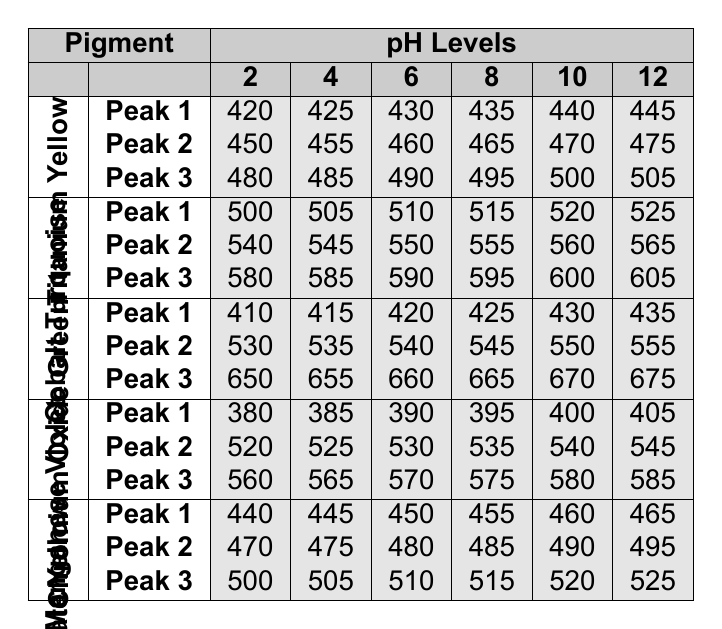What is the absorption peak of Titanium Yellow at pH level 6? By referring to the table, the absorption peak for Titanium Yellow at pH level 6 is specifically listed under Peak 1, Peak 2, and Peak 3. For Peak 1, the value is 430.
Answer: 430 What is the highest absorption value of Cobalt Turquoise at pH level 10? The table shows that for Cobalt Turquoise at pH level 10, the absorption peaks are 520, 560, and 600. Among these, 600 is the highest.
Answer: 600 Which pigment has the lowest absorption peak at pH level 2? By examining the table's data for all pigments at pH level 2, the lowest value can be observed. For Manganese Violet, it is 380, which is lower than the other pigments listed.
Answer: 380 At which pH level does Chromium Oxide Green show an absorption peak of 650? When checking the table for Chromium Oxide Green, the peak of 650 is specifically noted at pH level 2. This can be verified from the data.
Answer: 2 What is the average absorption peak value for Nickel Titanate Yellow across all pH levels? To find the average, sum the peaks for Nickel Titanate Yellow (440 + 445 + 450 + 455 + 460 + 465 = 2515), then divide by the number of peaks (6). Thus, the average absorption peak is 2515 / 6 = 419.17.
Answer: 419.17 Does Manganese Violet have a peak absorption value exceeding 550 at any pH level? By reviewing Manganese Violet's data, the maximum peak of 585 occurs at pH level 12, which exceeds 550. Thus, the statement is true.
Answer: Yes What is the difference between the highest peak of Chromium Oxide Green at pH level 12 and the lowest peak at pH level 2? The highest peak for Chromium Oxide Green at pH level 12 is 675, while the lowest peak at pH level 2 is 410. The difference is calculated as 675 - 410 = 265.
Answer: 265 Under which pigment does the absorption peak for pH level 8 equal to 575 occur? Looking at the table, the absorption peak of 575 at pH level 8 belongs to Manganese Violet. This can be seen directly in the data.
Answer: Manganese Violet Which pigment shows the least change in Peak 1 values as pH increases from 2 to 12? By analyzing the Peak 1 data, Titanium Yellow changes from 420 to 445, Cobalt Turquoise from 500 to 525, Chromium Oxide Green from 410 to 435, Manganese Violet from 380 to 405, and Nickel Titanate Yellow from 440 to 465. The least change occurs with Chromium Oxide Green (25).
Answer: Chromium Oxide Green 